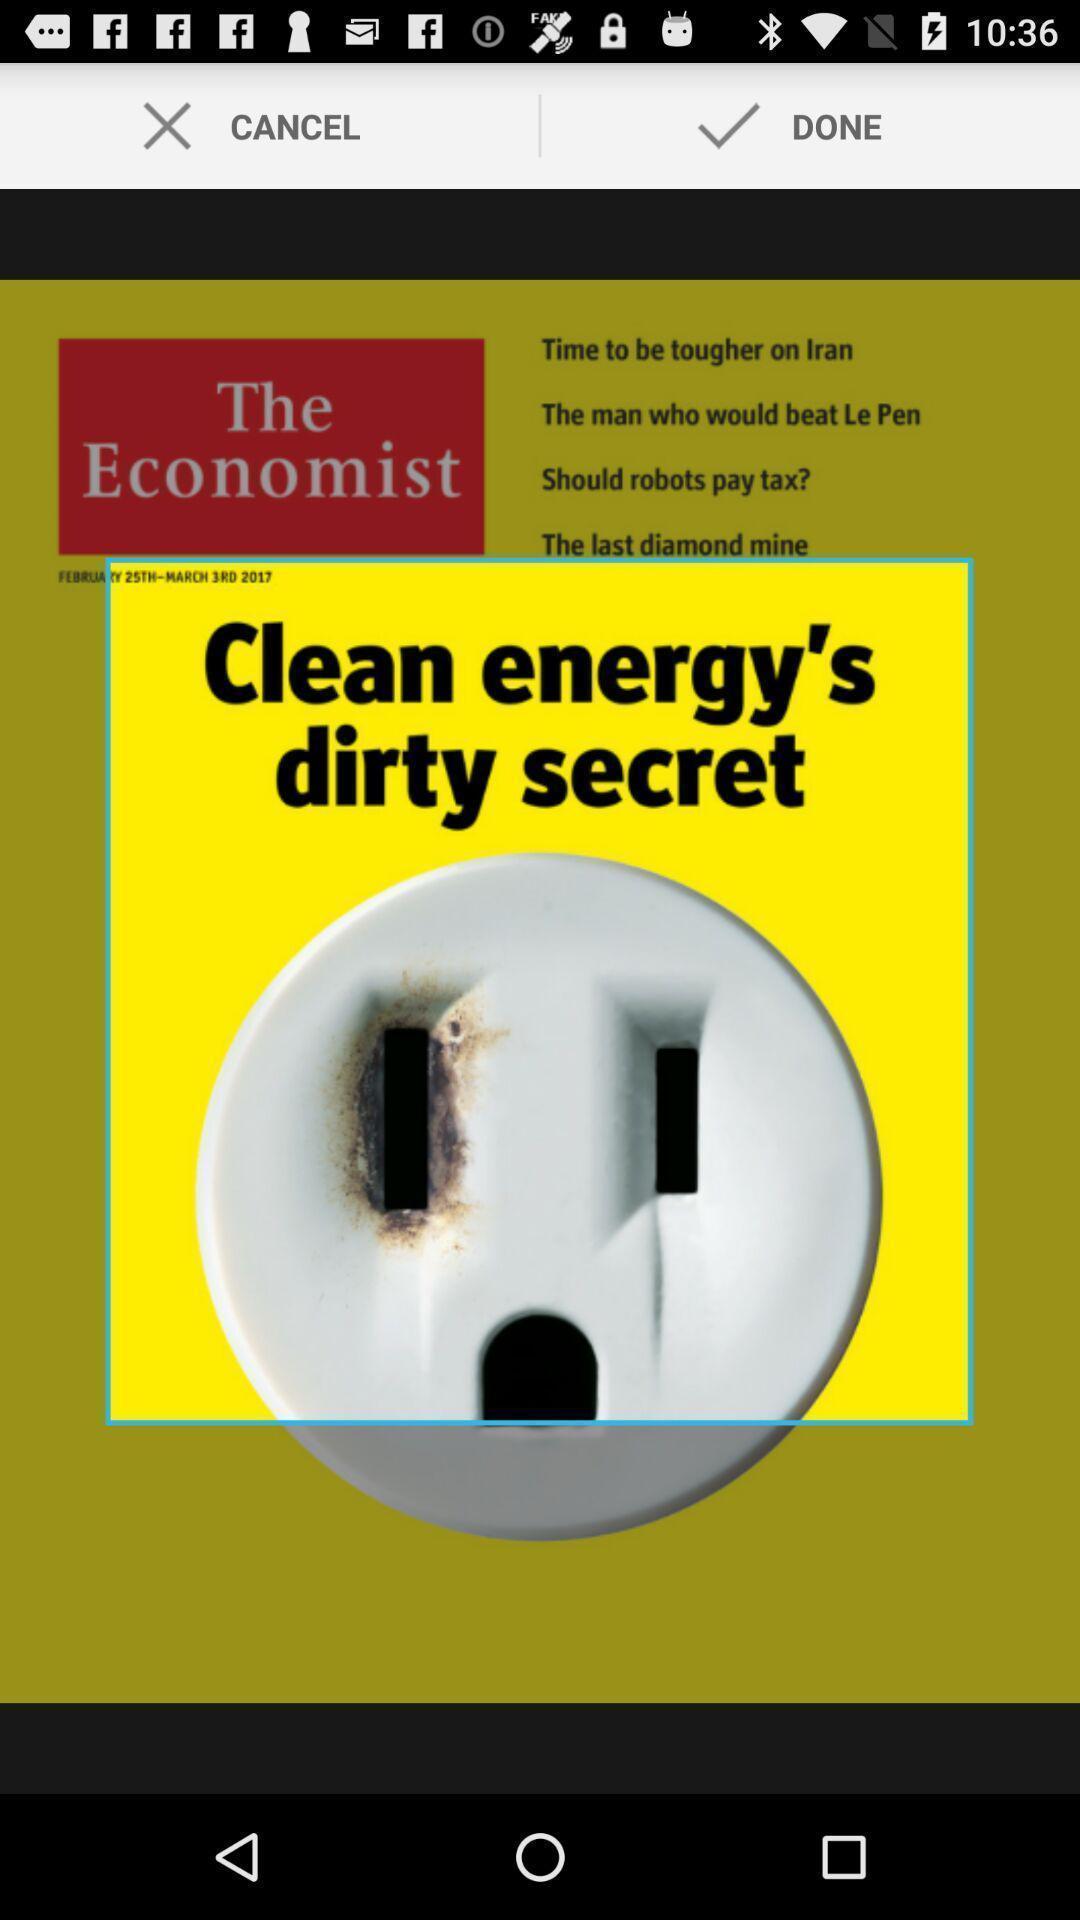Give me a narrative description of this picture. Page showing cropping of an image. 